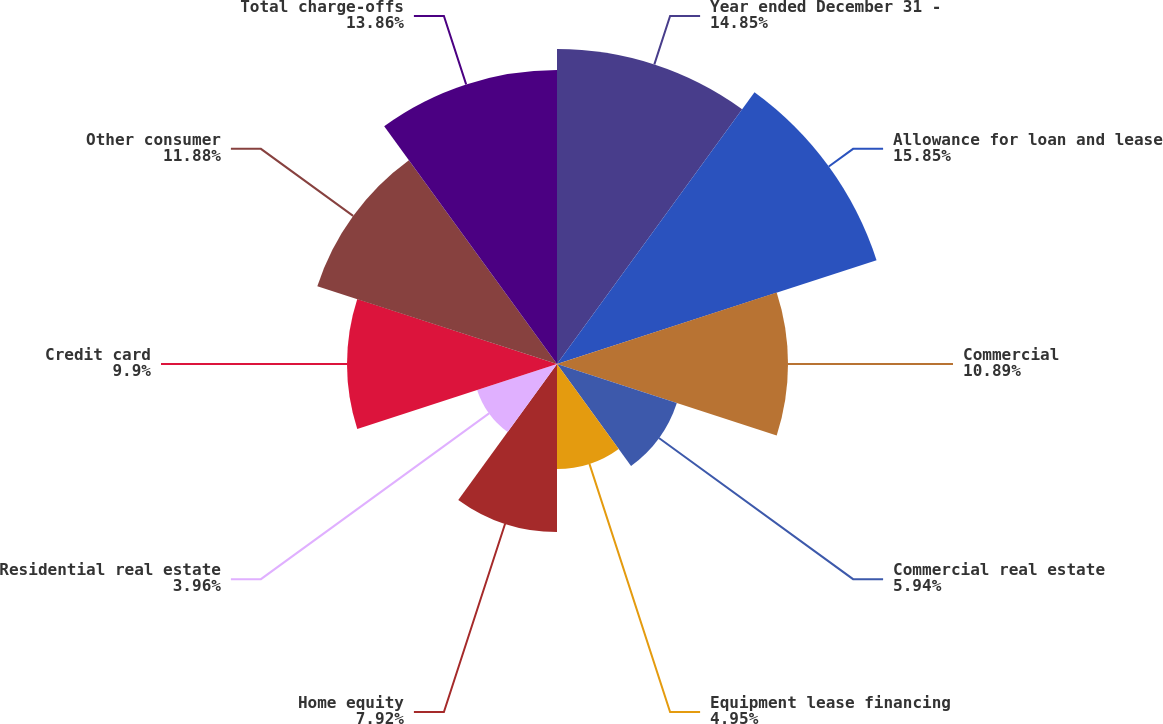<chart> <loc_0><loc_0><loc_500><loc_500><pie_chart><fcel>Year ended December 31 -<fcel>Allowance for loan and lease<fcel>Commercial<fcel>Commercial real estate<fcel>Equipment lease financing<fcel>Home equity<fcel>Residential real estate<fcel>Credit card<fcel>Other consumer<fcel>Total charge-offs<nl><fcel>14.85%<fcel>15.84%<fcel>10.89%<fcel>5.94%<fcel>4.95%<fcel>7.92%<fcel>3.96%<fcel>9.9%<fcel>11.88%<fcel>13.86%<nl></chart> 